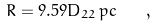<formula> <loc_0><loc_0><loc_500><loc_500>R = 9 . 5 9 D _ { 2 2 } \, p c \quad ,</formula> 